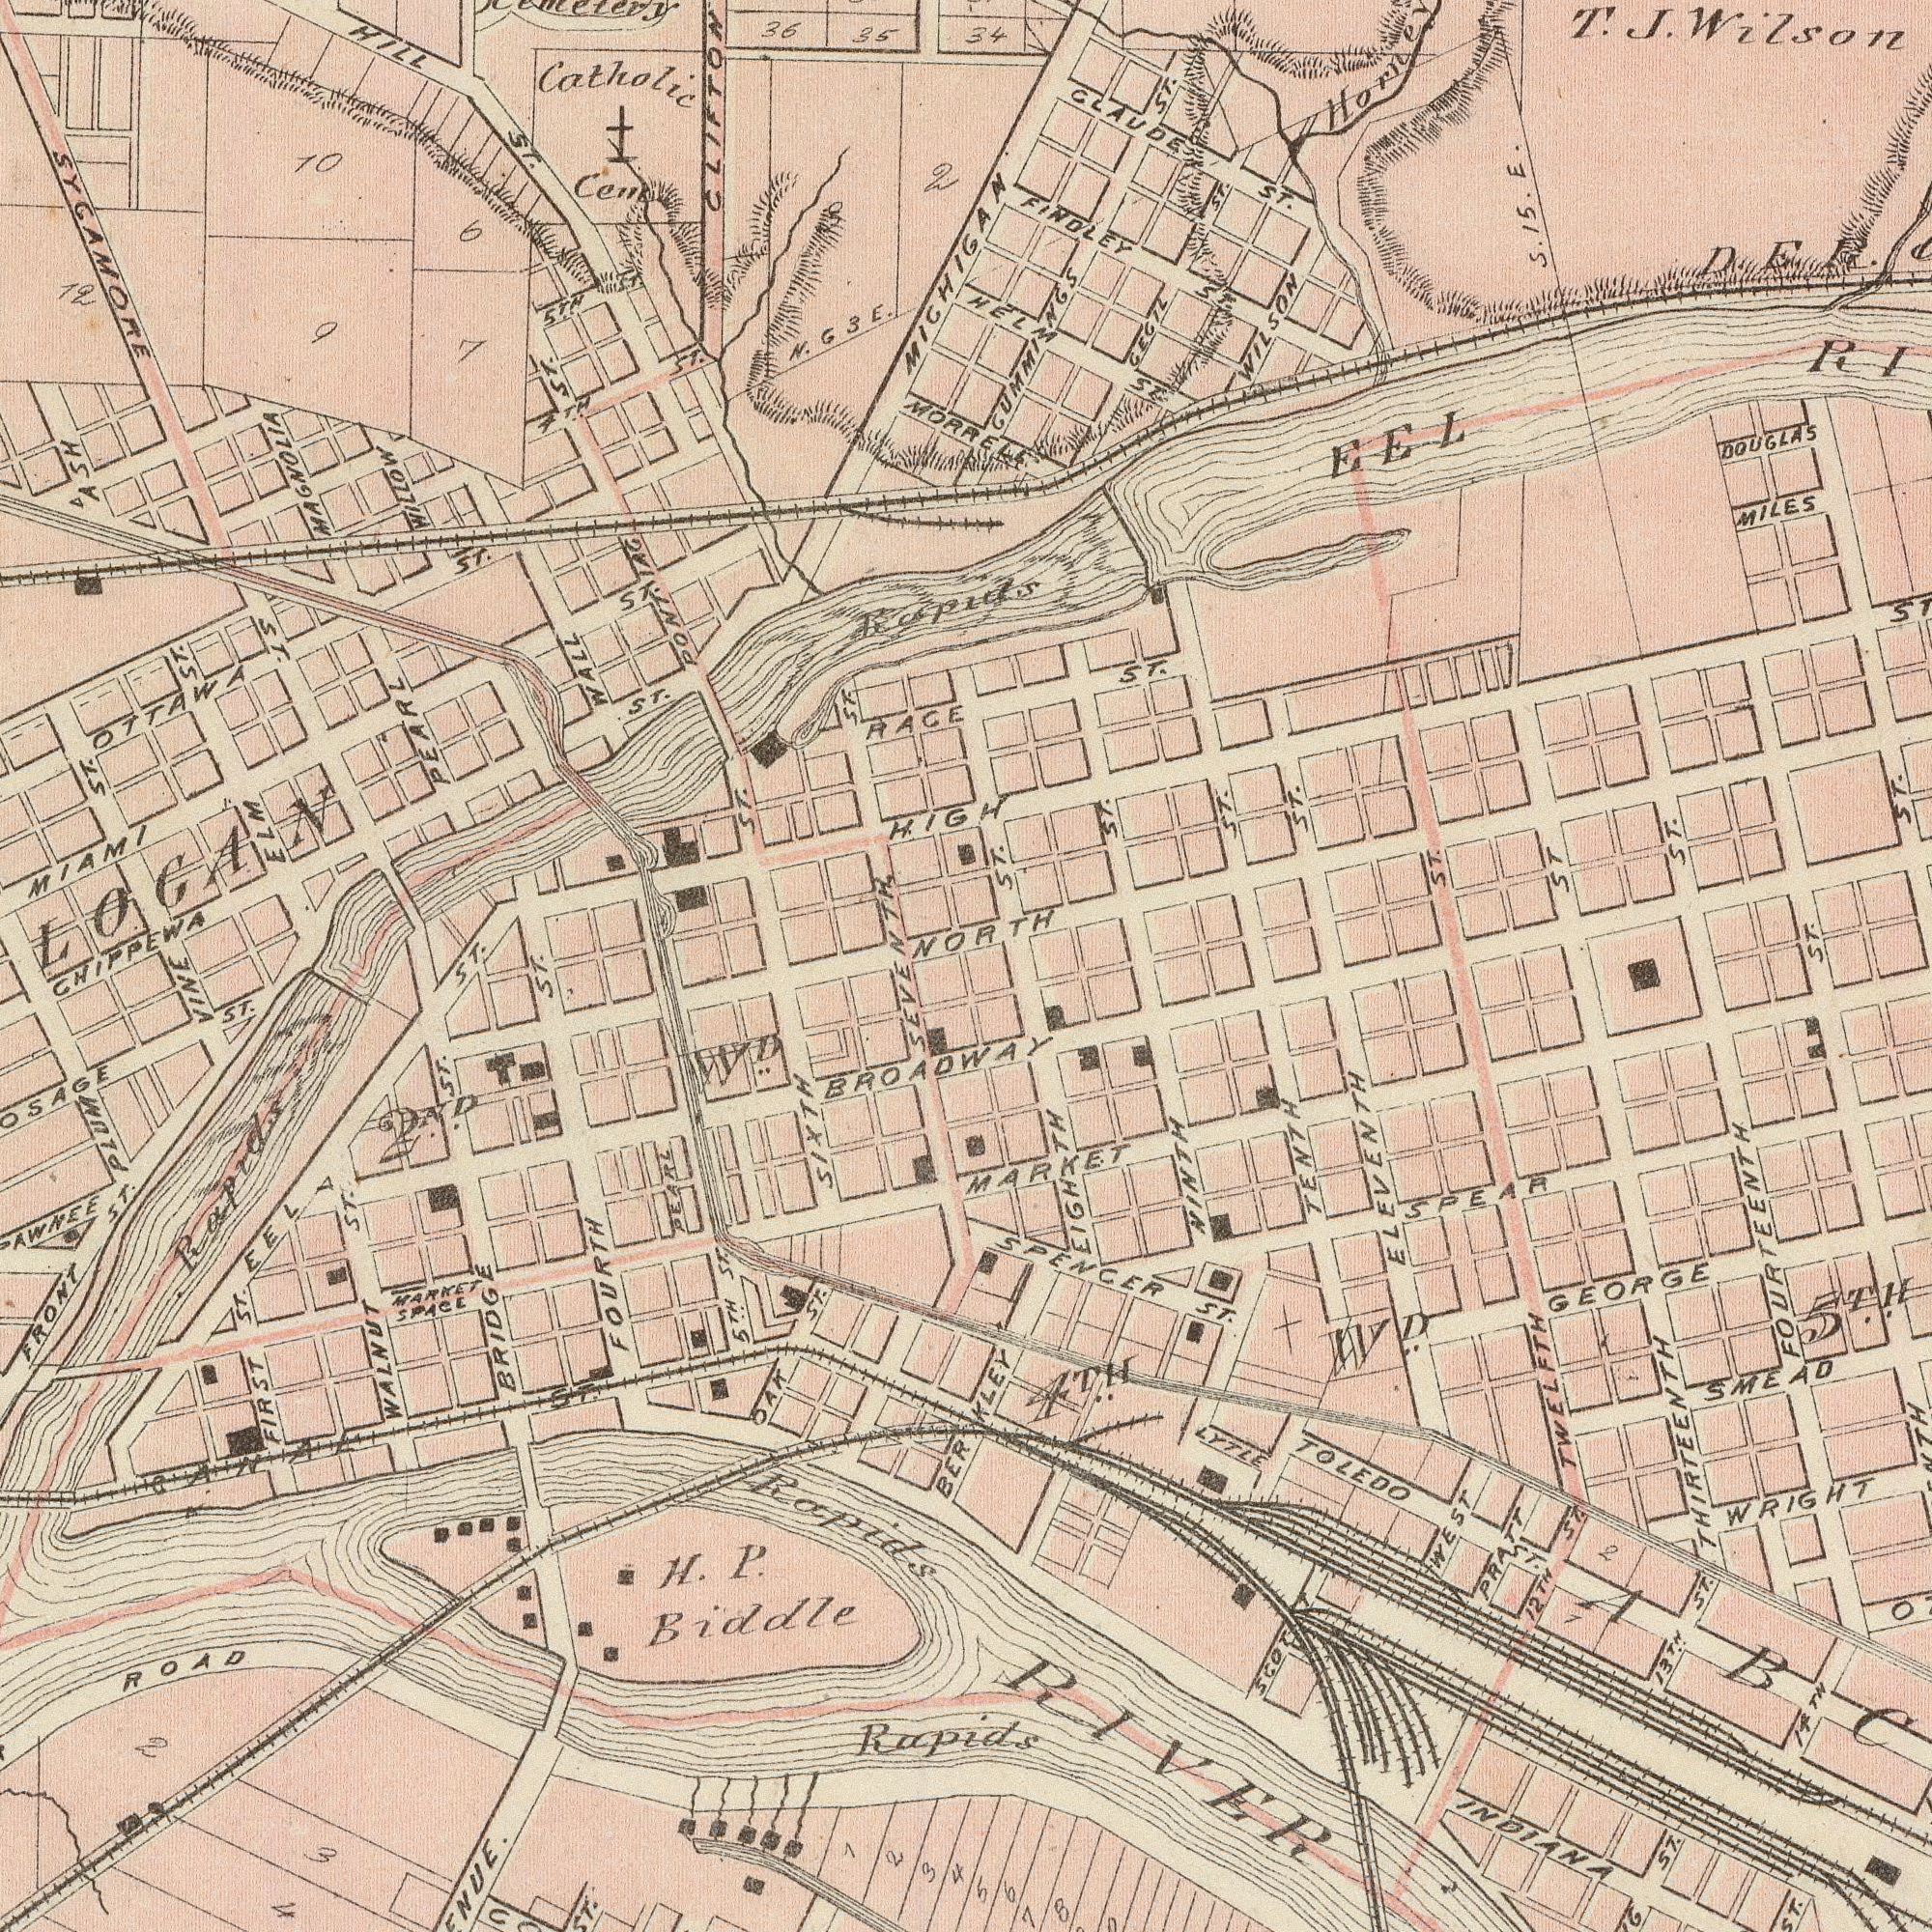What text is shown in the top-left quadrant? SYCAMORE ST. MIAMI ST. RACE WALL Cent Catholic HILL ST. CHIPPEWA ST. Rapids CLIFTON MICHIGAN WILLOW 35 36 OTTAWA ST. ELM ST. 5TH. ST. PEARL 10 12 Cemetery HIGH ST. ST. 2 N. G3 E. 6 9 7 ASH 4TH ST. SEVENTH ST. PONTIAG ST. MAGNOLIA LOGAN ST. What text can you see in the bottom-right section? FOURTEENTH THIRTEENTH TWELFTH ELEVENTH TENTH GEORGE WRIGHT INDIANA SMEAD SPEAR WEST WD TOLEDO ST. LYTLE RIVER MARKET ST. NINTH 12TH ST. SPENCER ST. 5TH. 2 13TH. ST. 1 PRATT 14TH EIGHTH 5 7 8 BERKLEY 4TH. What text is visible in the upper-right corner? ST. CLAUDE ST. MILES EEL T. J. Wilson FINDLEY ST. DOUGLAS ST. WILSON ST ST. ST. CECIL ST. 34 D. E. R. ST. ST. HELM ST. GUMMIINGS ST. S. 15. E. ST. ST. NORTH ST. What text appears in the bottom-left area of the image? Rapids ROAD H. P. Biddle ST. FOURTH ST. WD. FRONT ST. BRIDGE ST. EEL WALNUT ST. PLUM FIRST ST. 2ND OAK ST. MARKET SPACE VINE 2 Rapids 4 Rapids PEARL 5TH ST. CANAL ST. SIXTH BROADWAY 1 2 3 3 